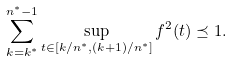Convert formula to latex. <formula><loc_0><loc_0><loc_500><loc_500>\sum _ { k = k ^ { * } } ^ { n ^ { * } - 1 } \sup _ { t \in [ k / n ^ { * } , ( k + 1 ) / n ^ { * } ] } f ^ { 2 } ( t ) \preceq 1 .</formula> 